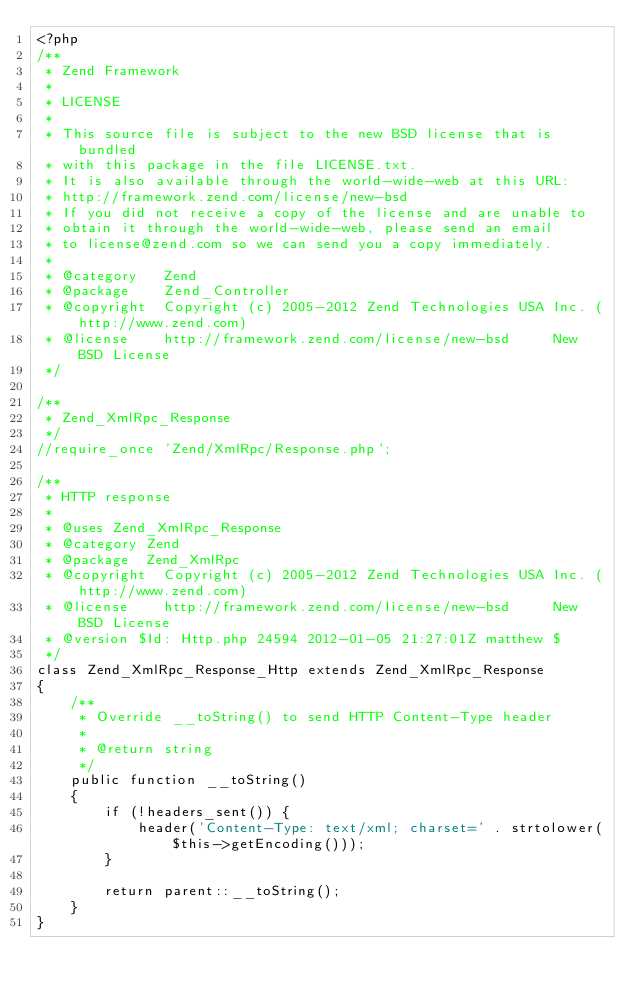Convert code to text. <code><loc_0><loc_0><loc_500><loc_500><_PHP_><?php
/**
 * Zend Framework
 *
 * LICENSE
 *
 * This source file is subject to the new BSD license that is bundled
 * with this package in the file LICENSE.txt.
 * It is also available through the world-wide-web at this URL:
 * http://framework.zend.com/license/new-bsd
 * If you did not receive a copy of the license and are unable to
 * obtain it through the world-wide-web, please send an email
 * to license@zend.com so we can send you a copy immediately.
 *
 * @category   Zend
 * @package    Zend_Controller
 * @copyright  Copyright (c) 2005-2012 Zend Technologies USA Inc. (http://www.zend.com)
 * @license    http://framework.zend.com/license/new-bsd     New BSD License
 */

/**
 * Zend_XmlRpc_Response
 */
//require_once 'Zend/XmlRpc/Response.php';

/**
 * HTTP response
 *
 * @uses Zend_XmlRpc_Response
 * @category Zend
 * @package  Zend_XmlRpc
 * @copyright  Copyright (c) 2005-2012 Zend Technologies USA Inc. (http://www.zend.com)
 * @license    http://framework.zend.com/license/new-bsd     New BSD License
 * @version $Id: Http.php 24594 2012-01-05 21:27:01Z matthew $
 */
class Zend_XmlRpc_Response_Http extends Zend_XmlRpc_Response
{
    /**
     * Override __toString() to send HTTP Content-Type header
     *
     * @return string
     */
    public function __toString()
    {
        if (!headers_sent()) {
            header('Content-Type: text/xml; charset=' . strtolower($this->getEncoding()));
        }

        return parent::__toString();
    }
}
</code> 